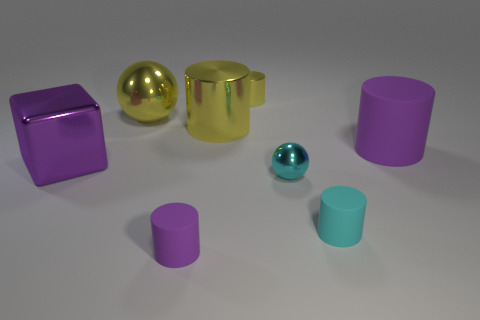Subtract all cyan cylinders. How many cylinders are left? 4 Subtract 2 cylinders. How many cylinders are left? 3 Subtract all big metal cylinders. How many cylinders are left? 4 Subtract all blue cylinders. Subtract all green cubes. How many cylinders are left? 5 Add 1 small purple cylinders. How many objects exist? 9 Subtract all cubes. How many objects are left? 7 Subtract 0 cyan blocks. How many objects are left? 8 Subtract all small cyan objects. Subtract all big cyan metallic objects. How many objects are left? 6 Add 7 yellow cylinders. How many yellow cylinders are left? 9 Add 2 big purple shiny cubes. How many big purple shiny cubes exist? 3 